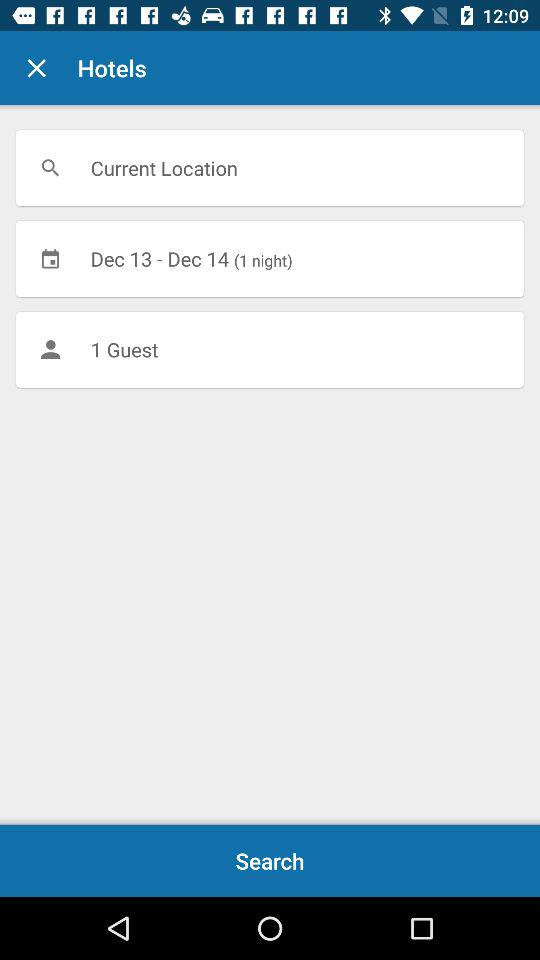How many days is the user searching for a hotel for?
Answer the question using a single word or phrase. 1 